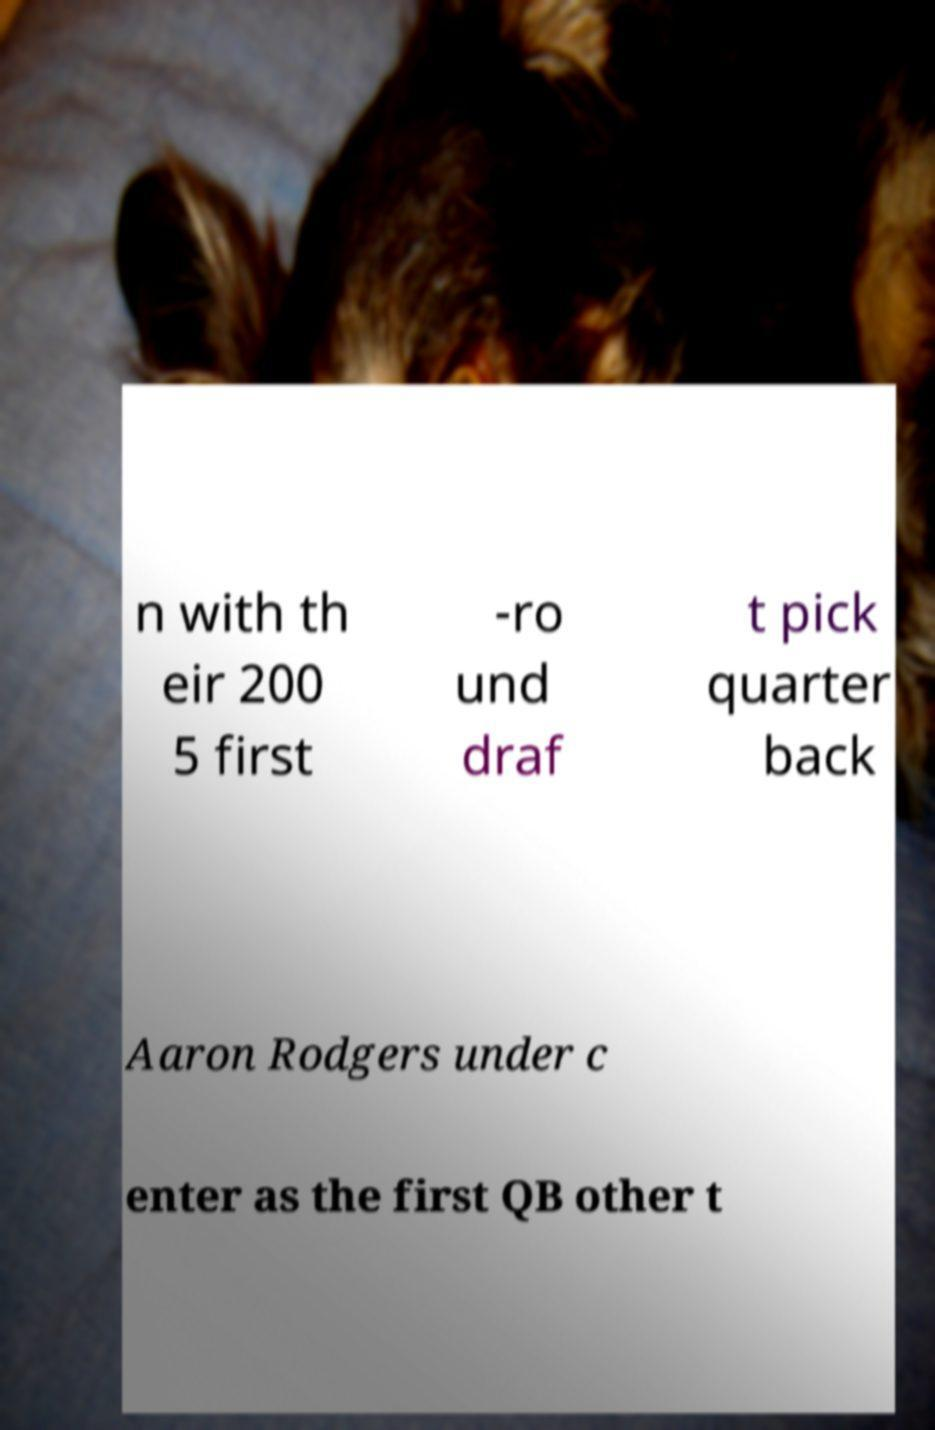Could you assist in decoding the text presented in this image and type it out clearly? n with th eir 200 5 first -ro und draf t pick quarter back Aaron Rodgers under c enter as the first QB other t 